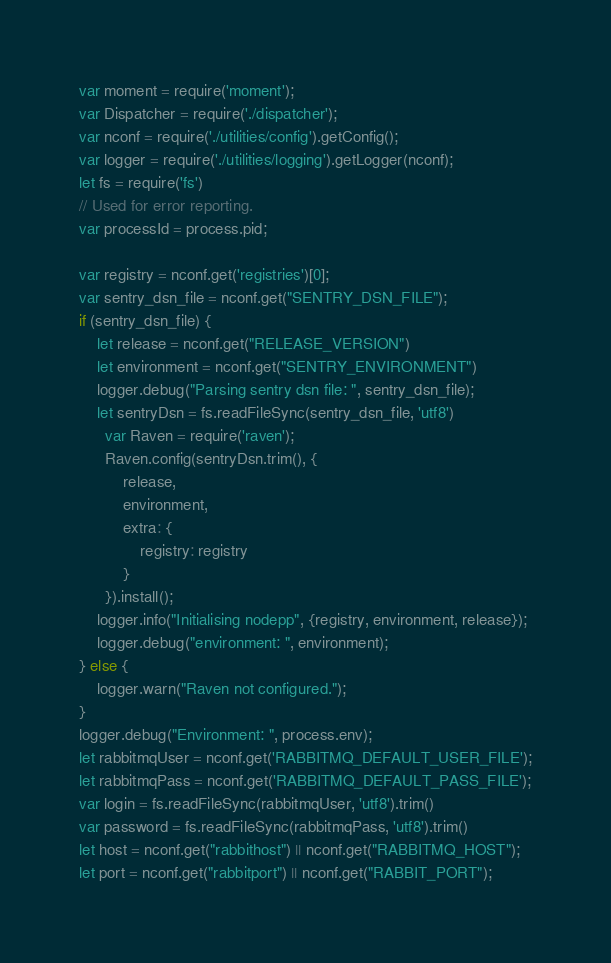Convert code to text. <code><loc_0><loc_0><loc_500><loc_500><_JavaScript_>var moment = require('moment');
var Dispatcher = require('./dispatcher');
var nconf = require('./utilities/config').getConfig();
var logger = require('./utilities/logging').getLogger(nconf);
let fs = require('fs')
// Used for error reporting. 
var processId = process.pid;

var registry = nconf.get('registries')[0];
var sentry_dsn_file = nconf.get("SENTRY_DSN_FILE");
if (sentry_dsn_file) {
    let release = nconf.get("RELEASE_VERSION")
    let environment = nconf.get("SENTRY_ENVIRONMENT")
    logger.debug("Parsing sentry dsn file: ", sentry_dsn_file);
    let sentryDsn = fs.readFileSync(sentry_dsn_file, 'utf8')
      var Raven = require('raven');
      Raven.config(sentryDsn.trim(), {
          release,
          environment,
          extra: {
              registry: registry
          }
      }).install();
    logger.info("Initialising nodepp", {registry, environment, release});
    logger.debug("environment: ", environment);
} else {
    logger.warn("Raven not configured.");
}
logger.debug("Environment: ", process.env);
let rabbitmqUser = nconf.get('RABBITMQ_DEFAULT_USER_FILE');
let rabbitmqPass = nconf.get('RABBITMQ_DEFAULT_PASS_FILE');
var login = fs.readFileSync(rabbitmqUser, 'utf8').trim()
var password = fs.readFileSync(rabbitmqPass, 'utf8').trim()
let host = nconf.get("rabbithost") || nconf.get("RABBITMQ_HOST");
let port = nconf.get("rabbitport") || nconf.get("RABBIT_PORT");</code> 